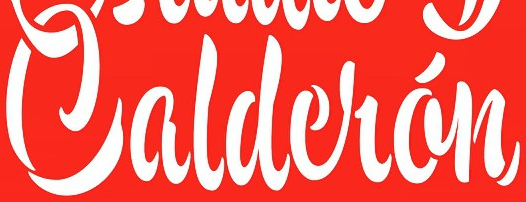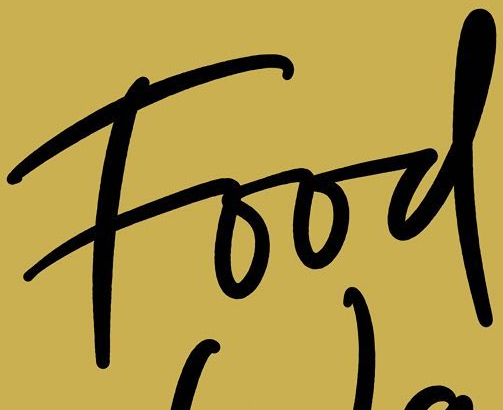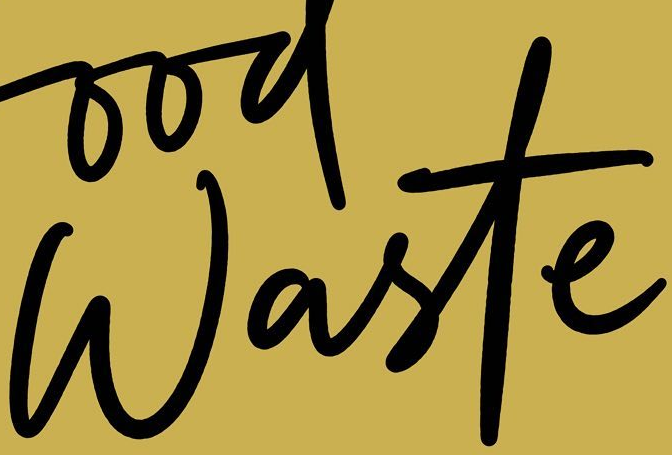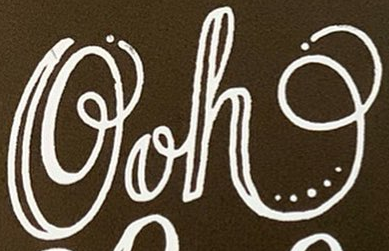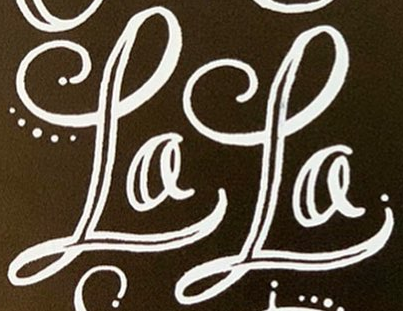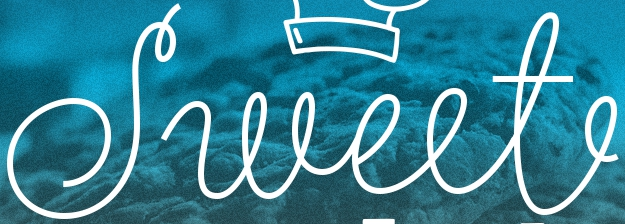Read the text from these images in sequence, separated by a semicolon. Caldelán; Food; Waste; Ooh; LaLa; Sweet 